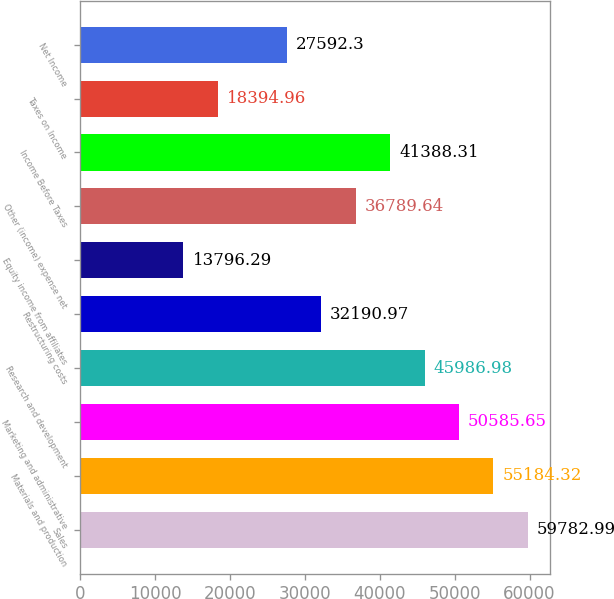<chart> <loc_0><loc_0><loc_500><loc_500><bar_chart><fcel>Sales<fcel>Materials and production<fcel>Marketing and administrative<fcel>Research and development<fcel>Restructuring costs<fcel>Equity income from affiliates<fcel>Other (income) expense net<fcel>Income Before Taxes<fcel>Taxes on Income<fcel>Net Income<nl><fcel>59783<fcel>55184.3<fcel>50585.7<fcel>45987<fcel>32191<fcel>13796.3<fcel>36789.6<fcel>41388.3<fcel>18395<fcel>27592.3<nl></chart> 